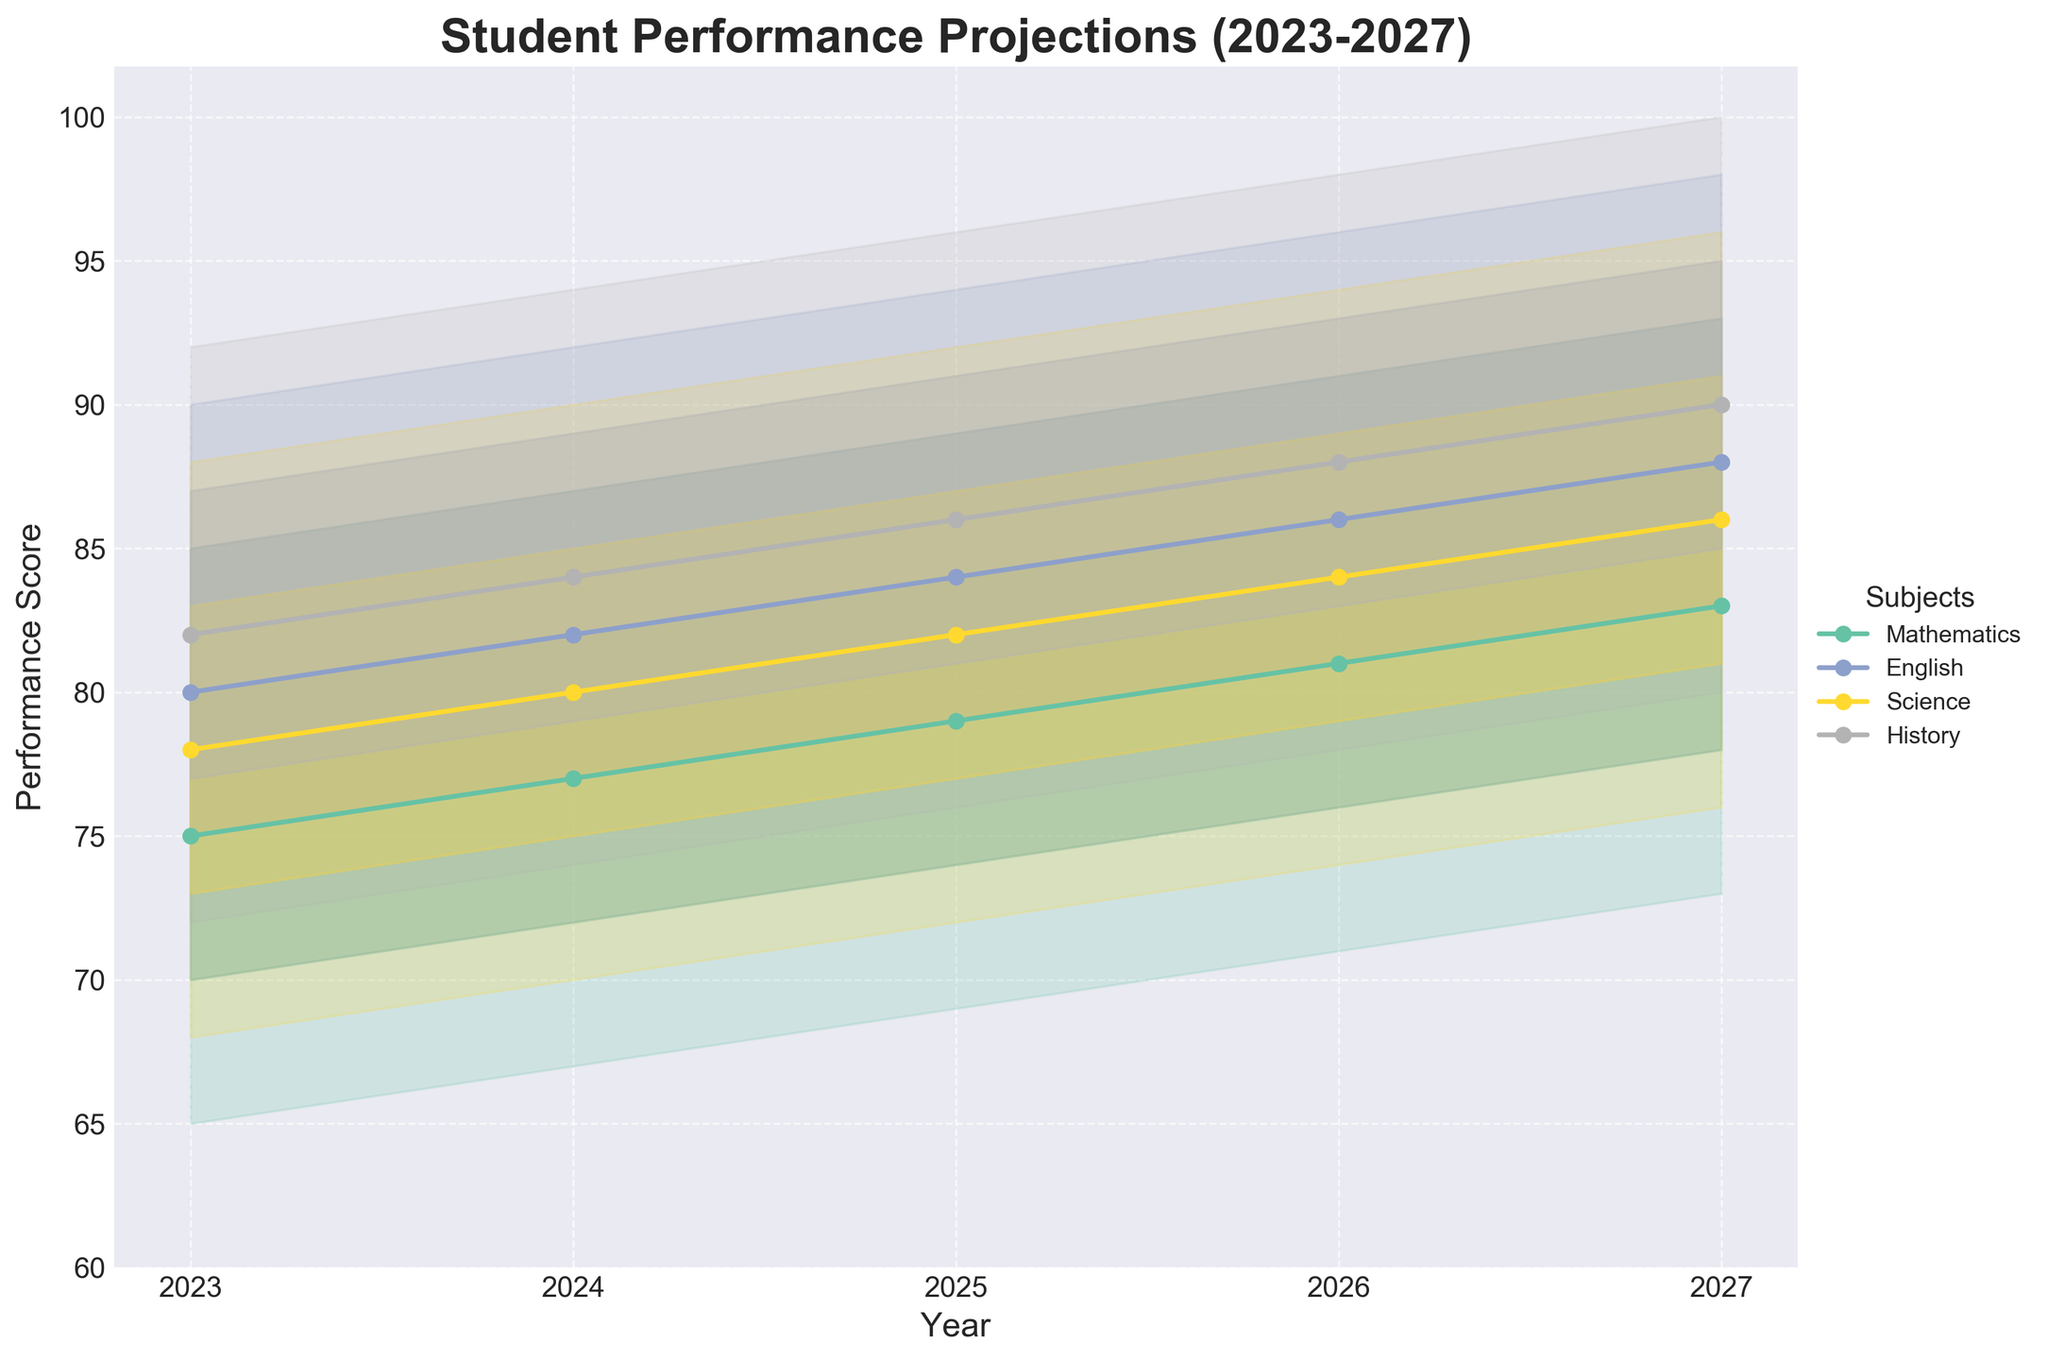What is the range (difference between Upper_10 and Lower_10) for Mathematics in 2023? For 2023, the Upper_10 value for Mathematics is 85 and the Lower_10 value is 65. The range is calculated as 85 - 65.
Answer: 20 Which subject has the highest median score in 2025? For 2025, the median scores are: Mathematics (79), English (84), Science (82), and History (86). The highest median score is 86 for History.
Answer: History Between 2023 and 2027, in which year does Science have the highest median score? The median scores for Science from 2023 to 2027 are: 78 (2023), 80 (2024), 82 (2025), 84 (2026), and 86 (2027). The highest median score is 86 in 2027.
Answer: 2027 Which subject shows the smallest increase in the median score from 2023 to 2027? The increase in the median scores from 2023 to 2027 for each subject is: Mathematics (75 to 83, increase of 8), English (80 to 88, increase of 8), Science (78 to 86, increase of 8), and History (82 to 90, increase of 8). Since all subjects have the same increase of 8, there is no subject with a smaller increase.
Answer: None What is the predicted performance score range for English in 2026 within the 25th to 75th percentile? For 2026, the Lower_25 value for English is 81 and the Upper_25 value is 91. Therefore, the range within the 25th to 75th percentile is 81 to 91.
Answer: 81 to 91 Compare the Upper_10 score for History in 2024 and 2025. Which year is higher? The Upper_10 score for History in 2024 is 94, and for 2025 it is 96. Therefore, 2025 has a higher score.
Answer: 2025 By how much does the median score for Mathematics change from 2023 to 2027? The median score for Mathematics in 2023 is 75 and in 2027 is 83. The change is 83 - 75 = 8.
Answer: 8 Which subject has the smallest interquartile range (difference between Upper_25 and Lower_25) in 2025? The interquartile ranges for subjects in 2025 are: Mathematics (84 - 74 = 10), English (89 - 79 = 10), Science (87 - 77 = 10), and History (91 - 81 = 10). Since all subjects have the same interquartile range of 10, there is no subject with a smaller range.
Answer: None In 2023, which subject has the lowest Lower_10 score, and what is that score? For 2023, the Lower_10 scores are: Mathematics (65), English (70), Science (68), and History (72). The lowest Lower_10 score is 65 for Mathematics.
Answer: Mathematics, 65 